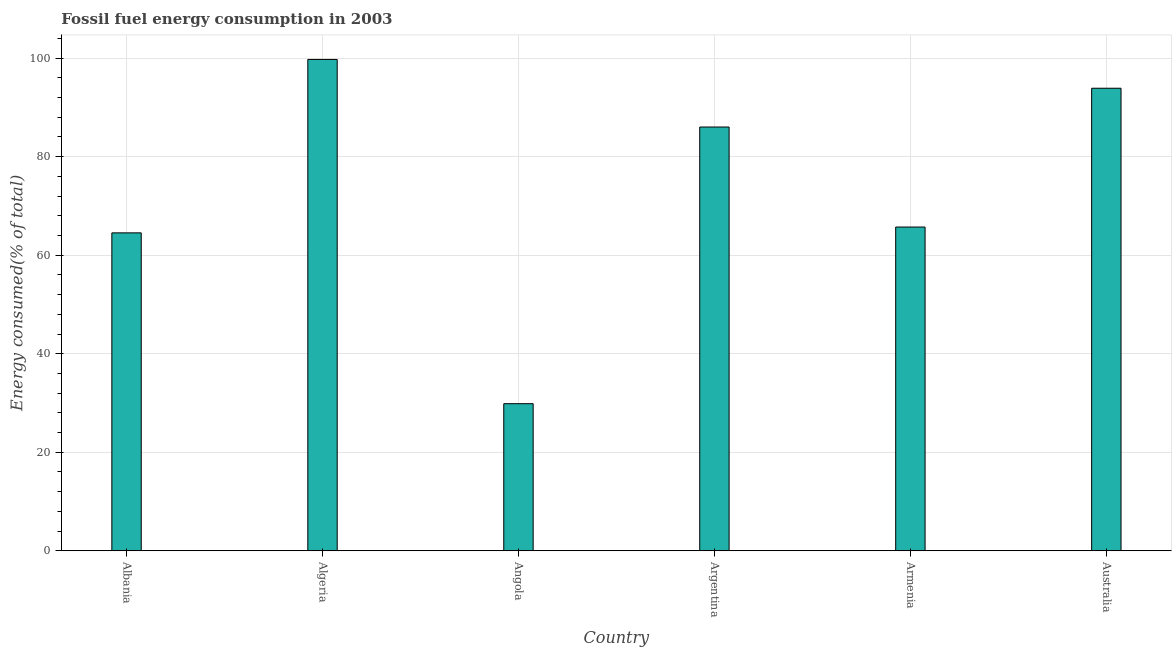Does the graph contain any zero values?
Keep it short and to the point. No. What is the title of the graph?
Your response must be concise. Fossil fuel energy consumption in 2003. What is the label or title of the Y-axis?
Ensure brevity in your answer.  Energy consumed(% of total). What is the fossil fuel energy consumption in Armenia?
Ensure brevity in your answer.  65.71. Across all countries, what is the maximum fossil fuel energy consumption?
Make the answer very short. 99.73. Across all countries, what is the minimum fossil fuel energy consumption?
Keep it short and to the point. 29.86. In which country was the fossil fuel energy consumption maximum?
Offer a very short reply. Algeria. In which country was the fossil fuel energy consumption minimum?
Your answer should be compact. Angola. What is the sum of the fossil fuel energy consumption?
Make the answer very short. 439.73. What is the difference between the fossil fuel energy consumption in Angola and Argentina?
Keep it short and to the point. -56.16. What is the average fossil fuel energy consumption per country?
Ensure brevity in your answer.  73.29. What is the median fossil fuel energy consumption?
Make the answer very short. 75.86. What is the ratio of the fossil fuel energy consumption in Algeria to that in Armenia?
Keep it short and to the point. 1.52. Is the fossil fuel energy consumption in Armenia less than that in Australia?
Keep it short and to the point. Yes. Is the difference between the fossil fuel energy consumption in Albania and Australia greater than the difference between any two countries?
Offer a terse response. No. What is the difference between the highest and the second highest fossil fuel energy consumption?
Your answer should be compact. 5.84. What is the difference between the highest and the lowest fossil fuel energy consumption?
Give a very brief answer. 69.88. In how many countries, is the fossil fuel energy consumption greater than the average fossil fuel energy consumption taken over all countries?
Provide a short and direct response. 3. Are all the bars in the graph horizontal?
Ensure brevity in your answer.  No. How many countries are there in the graph?
Offer a very short reply. 6. What is the Energy consumed(% of total) in Albania?
Offer a terse response. 64.53. What is the Energy consumed(% of total) of Algeria?
Your answer should be compact. 99.73. What is the Energy consumed(% of total) in Angola?
Offer a terse response. 29.86. What is the Energy consumed(% of total) in Argentina?
Give a very brief answer. 86.01. What is the Energy consumed(% of total) in Armenia?
Ensure brevity in your answer.  65.71. What is the Energy consumed(% of total) in Australia?
Provide a succinct answer. 93.89. What is the difference between the Energy consumed(% of total) in Albania and Algeria?
Keep it short and to the point. -35.2. What is the difference between the Energy consumed(% of total) in Albania and Angola?
Make the answer very short. 34.67. What is the difference between the Energy consumed(% of total) in Albania and Argentina?
Your answer should be very brief. -21.49. What is the difference between the Energy consumed(% of total) in Albania and Armenia?
Your response must be concise. -1.18. What is the difference between the Energy consumed(% of total) in Albania and Australia?
Give a very brief answer. -29.36. What is the difference between the Energy consumed(% of total) in Algeria and Angola?
Your answer should be very brief. 69.88. What is the difference between the Energy consumed(% of total) in Algeria and Argentina?
Give a very brief answer. 13.72. What is the difference between the Energy consumed(% of total) in Algeria and Armenia?
Your answer should be very brief. 34.02. What is the difference between the Energy consumed(% of total) in Algeria and Australia?
Provide a short and direct response. 5.85. What is the difference between the Energy consumed(% of total) in Angola and Argentina?
Your response must be concise. -56.16. What is the difference between the Energy consumed(% of total) in Angola and Armenia?
Keep it short and to the point. -35.86. What is the difference between the Energy consumed(% of total) in Angola and Australia?
Provide a short and direct response. -64.03. What is the difference between the Energy consumed(% of total) in Argentina and Armenia?
Your response must be concise. 20.3. What is the difference between the Energy consumed(% of total) in Argentina and Australia?
Keep it short and to the point. -7.87. What is the difference between the Energy consumed(% of total) in Armenia and Australia?
Keep it short and to the point. -28.18. What is the ratio of the Energy consumed(% of total) in Albania to that in Algeria?
Make the answer very short. 0.65. What is the ratio of the Energy consumed(% of total) in Albania to that in Angola?
Your answer should be very brief. 2.16. What is the ratio of the Energy consumed(% of total) in Albania to that in Argentina?
Give a very brief answer. 0.75. What is the ratio of the Energy consumed(% of total) in Albania to that in Australia?
Keep it short and to the point. 0.69. What is the ratio of the Energy consumed(% of total) in Algeria to that in Angola?
Provide a short and direct response. 3.34. What is the ratio of the Energy consumed(% of total) in Algeria to that in Argentina?
Ensure brevity in your answer.  1.16. What is the ratio of the Energy consumed(% of total) in Algeria to that in Armenia?
Make the answer very short. 1.52. What is the ratio of the Energy consumed(% of total) in Algeria to that in Australia?
Make the answer very short. 1.06. What is the ratio of the Energy consumed(% of total) in Angola to that in Argentina?
Make the answer very short. 0.35. What is the ratio of the Energy consumed(% of total) in Angola to that in Armenia?
Your response must be concise. 0.45. What is the ratio of the Energy consumed(% of total) in Angola to that in Australia?
Make the answer very short. 0.32. What is the ratio of the Energy consumed(% of total) in Argentina to that in Armenia?
Provide a succinct answer. 1.31. What is the ratio of the Energy consumed(% of total) in Argentina to that in Australia?
Ensure brevity in your answer.  0.92. 